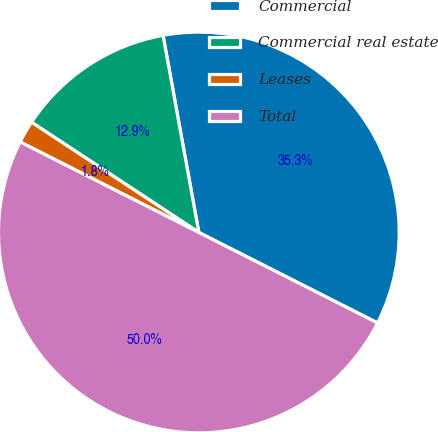<chart> <loc_0><loc_0><loc_500><loc_500><pie_chart><fcel>Commercial<fcel>Commercial real estate<fcel>Leases<fcel>Total<nl><fcel>35.32%<fcel>12.87%<fcel>1.81%<fcel>50.0%<nl></chart> 